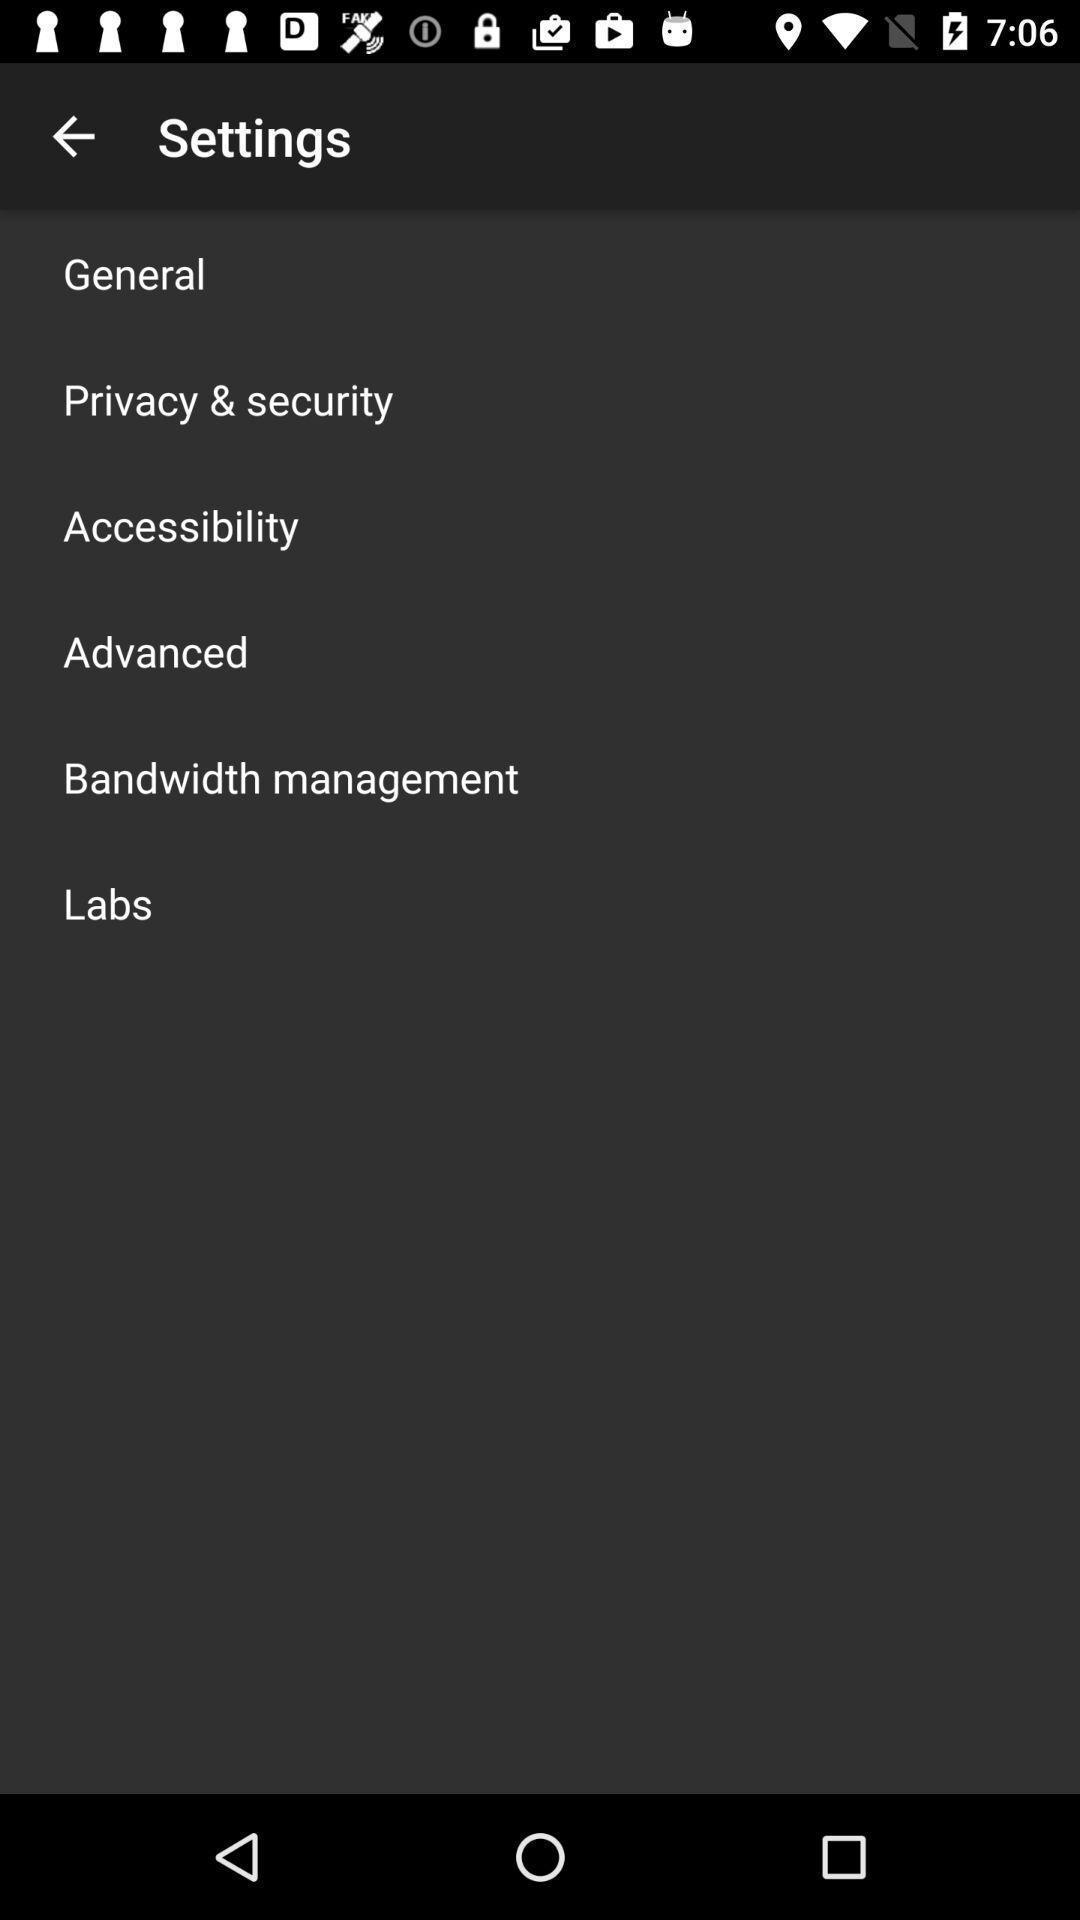Tell me about the visual elements in this screen capture. Settings page. 